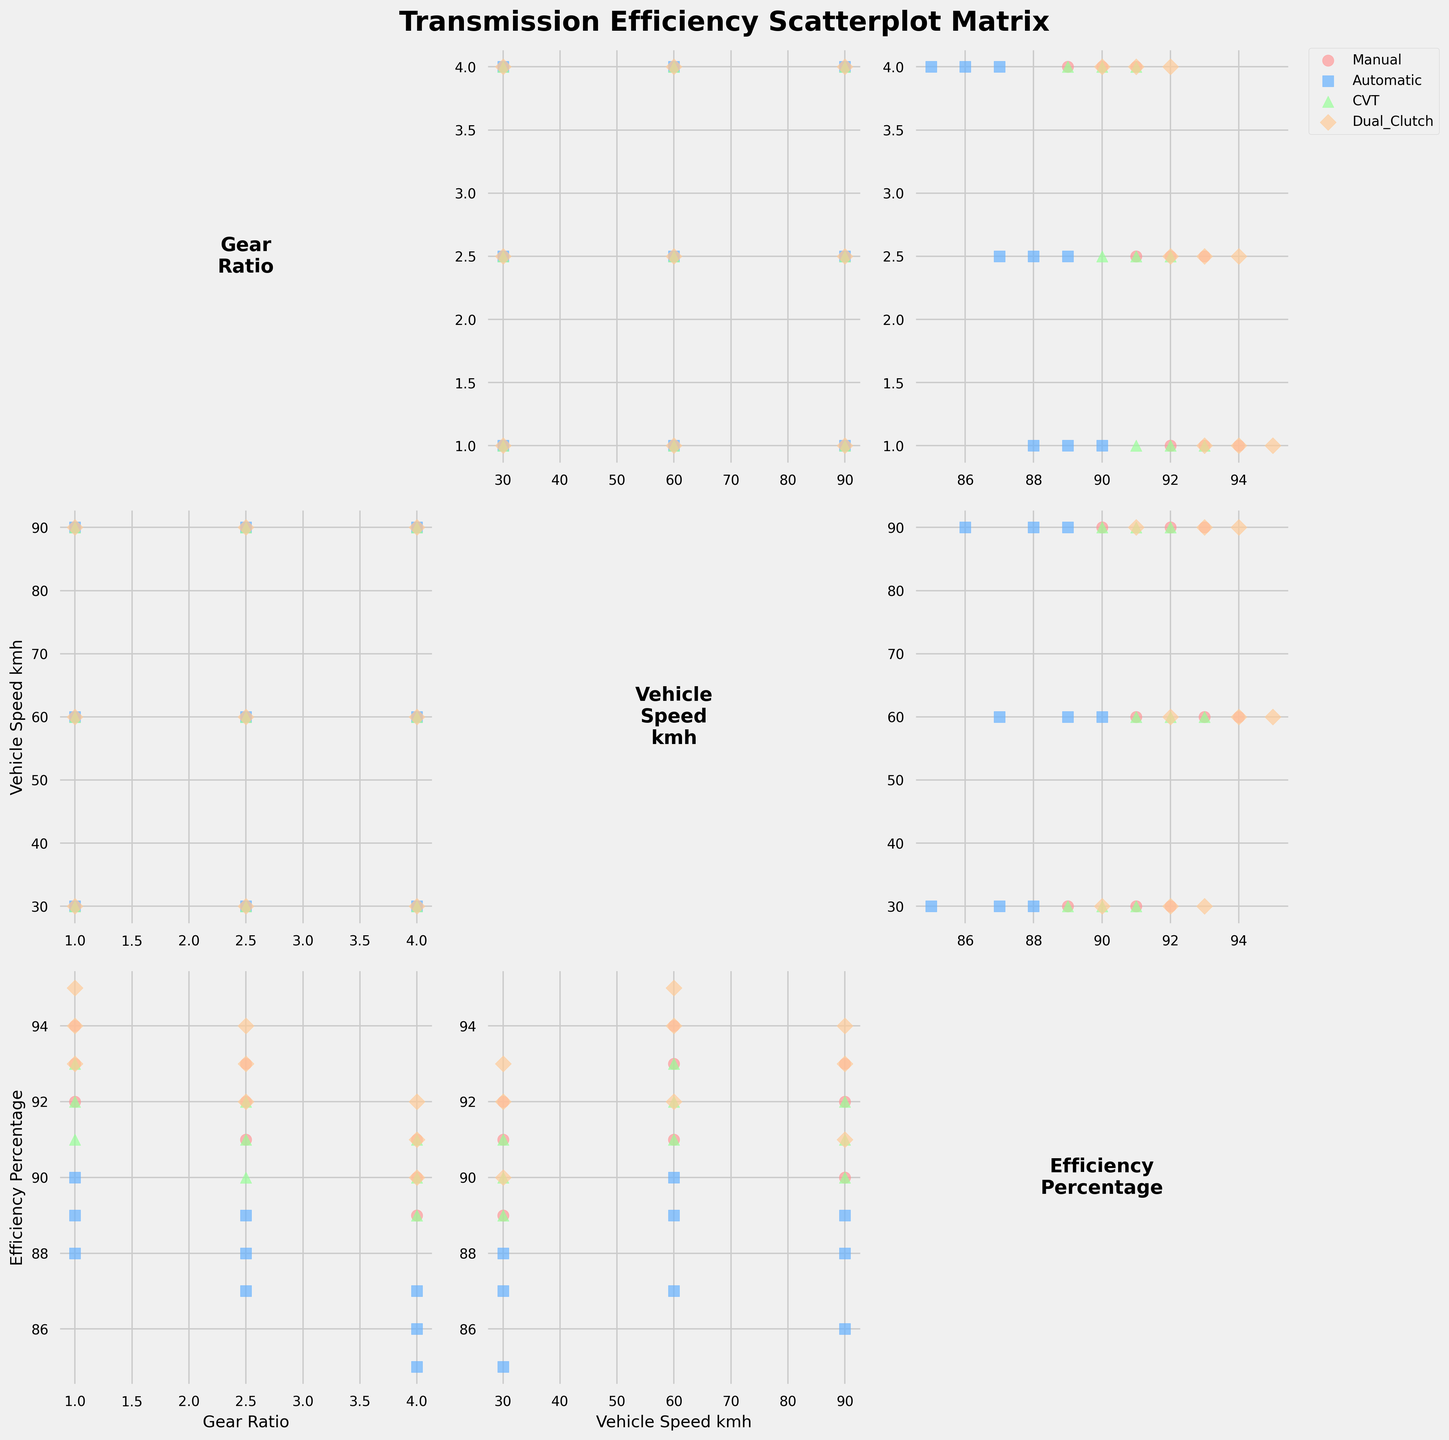What is the title of the plot? The title is located at the top of the plot and usually summarizes the main topic or focus.
Answer: Transmission Efficiency Scatterplot Matrix Which transmission type uses the 'o' marker? The markers shape for each transmission type is specified in the plot's legend. Manual transmissions are represented by 'o' markers.
Answer: Manual What variables are plotted on the axes? Each subplot has different variable combinations, shown by the labels on the axes. The variables are "Gear Ratio", "Vehicle Speed kmh", and "Efficiency Percentage".
Answer: Gear Ratio, Vehicle Speed kmh, Efficiency Percentage Which transmission type has the highest efficiency percentage at a vehicle speed of 60 km/h and gear ratio of 1.0? To find the highest efficiency percentage within the given conditions, locate the corresponding data points and compare their efficiency percentages. Dual Clutch transmission shows the highest percentage in this scenario.
Answer: Dual Clutch Which transmission type shows the lowest efficiency percentage on average across all gear ratios and vehicle speeds? Calculate the average efficiency percentage for each transmission type by summing their efficiencies and dividing by the number of data points. Automatic transmission has the lowest average efficiency percentage.
Answer: Automatic What are the colors used to represent CVT transmission in the scatterplots? The colors are specified in the legend, with each transmission type assigned a different color. The CVT transmission is represented in a shade of green.
Answer: Green How does the efficiency of Manual transmissions change with increasing vehicle speed at a gear ratio of 1.0? Examine the scatter plot where the x-axis is Vehicle Speed kmh and the y-axis is Efficiency Percentage for Manual transmissions.  The efficiency percentage increases slightly before showing a slight decrease at higher speeds.
Answer: Initially increases, then slightly decreases Are there any transmission types that show a distinct clustering of data points when comparing efficiency percentage against gear ratio? Look for patterns or clusters within each transmission type across the relevant scatterplots. Manual and Dual Clutch transmissions show distinct clusters in these plots.
Answer: Manual, Dual Clutch What is the impact of higher gear ratios on the efficiency of Automatic transmissions? Compare the efficiency percentages of Automatic transmissions at increasing gear ratios by looking at the subplots. The efficiency generally decreases as the gear ratio increases.
Answer: Decreases Which transmission type has the most tightly clustered data points in the subplot comparing Vehicle Speed kmh and Efficiency Percentage? Observe the scatterplots to identify which transmission type's data points are closest together. Dual Clutch transmissions have the most tightly clustered data points.
Answer: Dual Clutch 